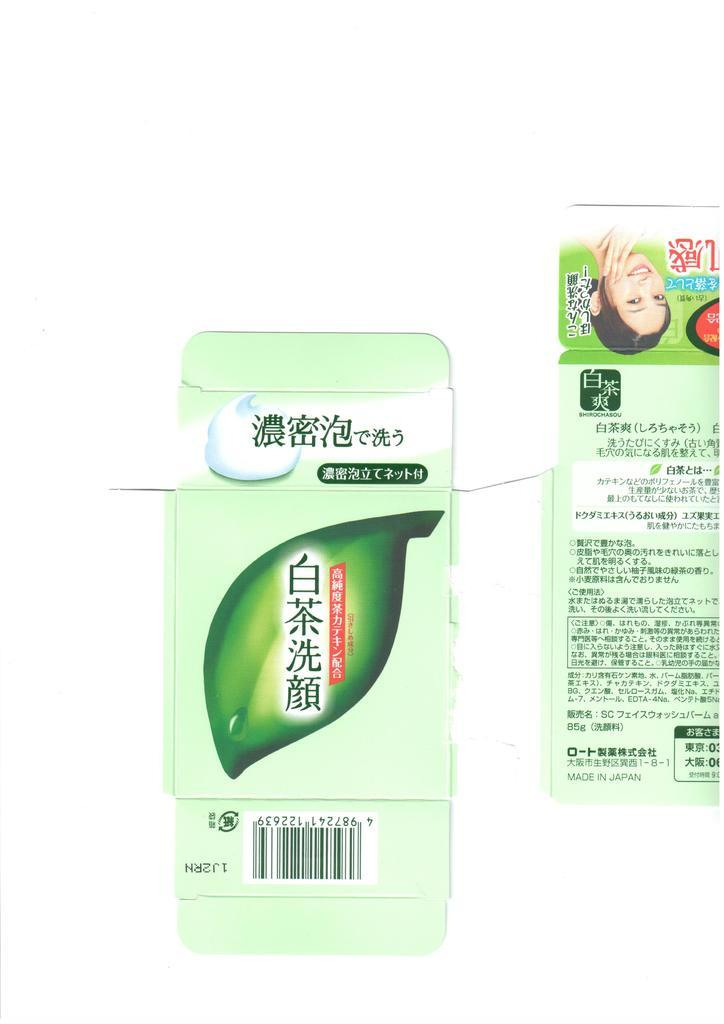What can be seen in the image that contains information or identification? There are tags in the image. What type of content is present on the tags? The tags contain text and logos. What type of collar is visible on the tags in the image? There is no collar present in the image; the image only contains tags with text and logos. 